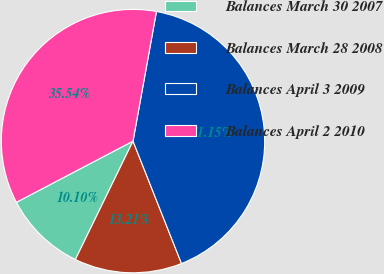Convert chart. <chart><loc_0><loc_0><loc_500><loc_500><pie_chart><fcel>Balances March 30 2007<fcel>Balances March 28 2008<fcel>Balances April 3 2009<fcel>Balances April 2 2010<nl><fcel>10.1%<fcel>13.21%<fcel>41.15%<fcel>35.54%<nl></chart> 